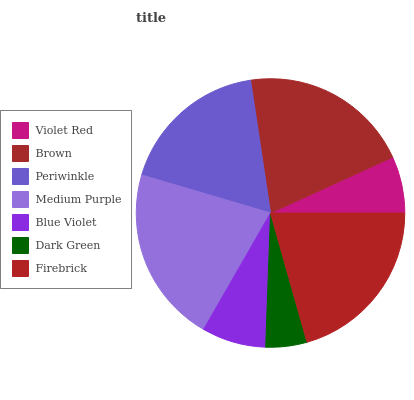Is Dark Green the minimum?
Answer yes or no. Yes. Is Medium Purple the maximum?
Answer yes or no. Yes. Is Brown the minimum?
Answer yes or no. No. Is Brown the maximum?
Answer yes or no. No. Is Brown greater than Violet Red?
Answer yes or no. Yes. Is Violet Red less than Brown?
Answer yes or no. Yes. Is Violet Red greater than Brown?
Answer yes or no. No. Is Brown less than Violet Red?
Answer yes or no. No. Is Periwinkle the high median?
Answer yes or no. Yes. Is Periwinkle the low median?
Answer yes or no. Yes. Is Medium Purple the high median?
Answer yes or no. No. Is Blue Violet the low median?
Answer yes or no. No. 